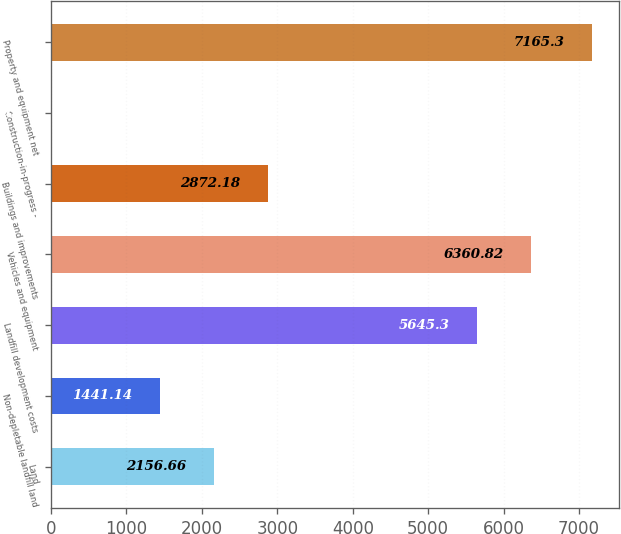Convert chart. <chart><loc_0><loc_0><loc_500><loc_500><bar_chart><fcel>Land<fcel>Non-depletable landfill land<fcel>Landfill development costs<fcel>Vehicles and equipment<fcel>Buildings and improvements<fcel>Construction-in-progress -<fcel>Property and equipment net<nl><fcel>2156.66<fcel>1441.14<fcel>5645.3<fcel>6360.82<fcel>2872.18<fcel>10.1<fcel>7165.3<nl></chart> 